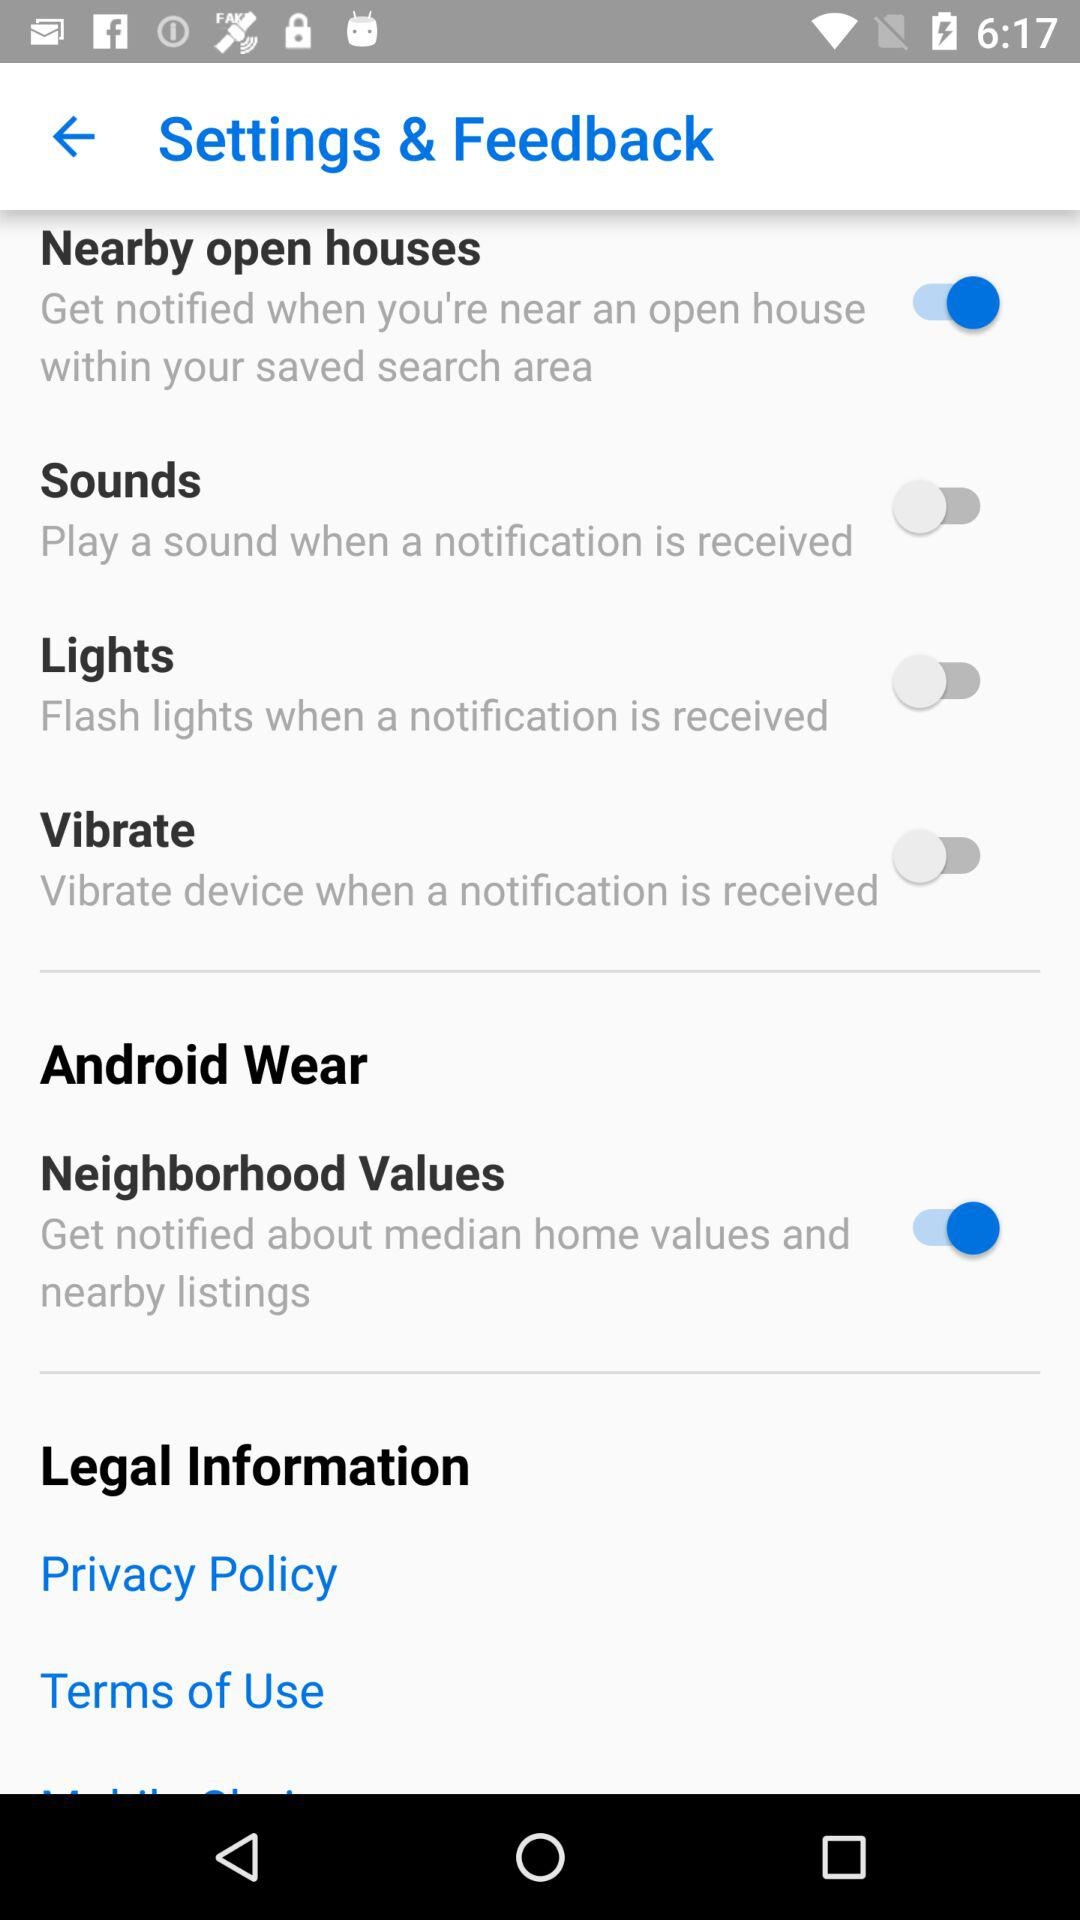What is the status of the "Neighborhood Values" settings? The status is "on". 